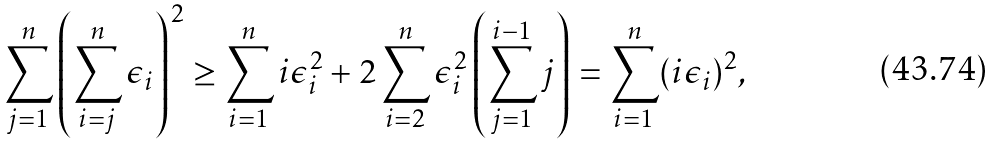<formula> <loc_0><loc_0><loc_500><loc_500>\sum _ { j = 1 } ^ { n } \left ( \sum _ { i = j } ^ { n } \epsilon _ { i } \right ) ^ { 2 } \geq \sum _ { i = 1 } ^ { n } i \epsilon ^ { 2 } _ { i } + 2 \sum _ { i = 2 } ^ { n } \epsilon _ { i } ^ { 2 } \left ( \sum _ { j = 1 } ^ { i - 1 } j \right ) = \sum _ { i = 1 } ^ { n } ( i \epsilon _ { i } ) ^ { 2 } ,</formula> 